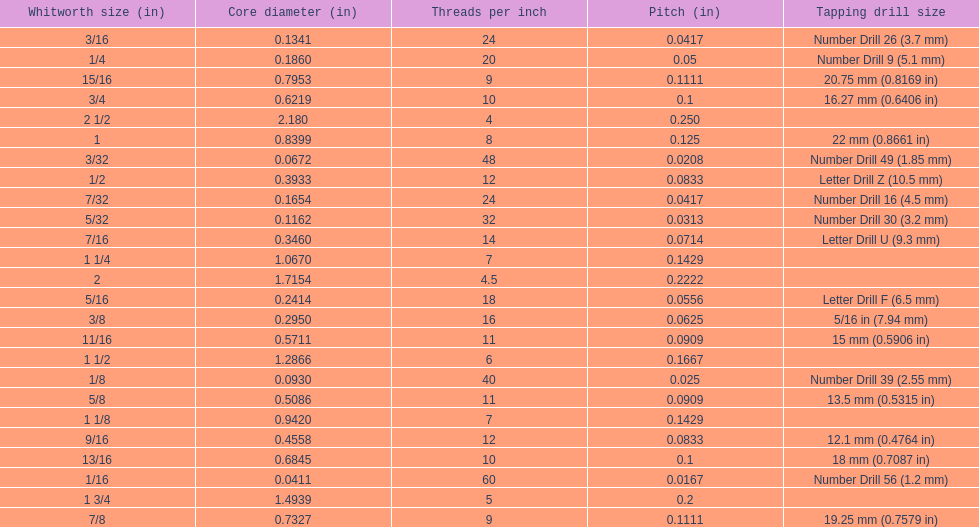Does any whitworth size have the same core diameter as the number drill 26? 3/16. 